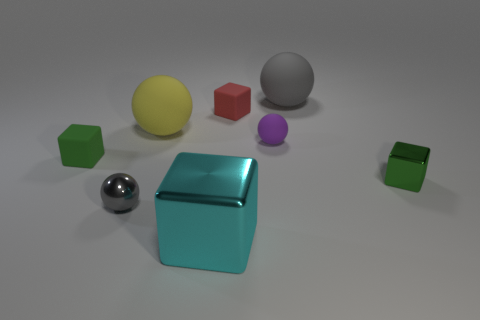What is the color of the other big sphere that is the same material as the big gray sphere?
Your response must be concise. Yellow. How many objects are either tiny green rubber cubes or large purple metal cylinders?
Your response must be concise. 1. The other metal ball that is the same size as the purple ball is what color?
Your answer should be very brief. Gray. How many things are either large cyan cubes that are in front of the tiny purple matte object or green blocks?
Keep it short and to the point. 3. How many other objects are there of the same size as the purple matte ball?
Provide a succinct answer. 4. How big is the gray sphere in front of the red matte object?
Ensure brevity in your answer.  Small. The big yellow thing that is the same material as the tiny purple ball is what shape?
Provide a short and direct response. Sphere. Is there anything else of the same color as the large metallic block?
Ensure brevity in your answer.  No. There is a large matte thing that is behind the tiny block behind the purple rubber object; what color is it?
Your answer should be compact. Gray. What number of large things are green matte objects or blue matte spheres?
Give a very brief answer. 0. 